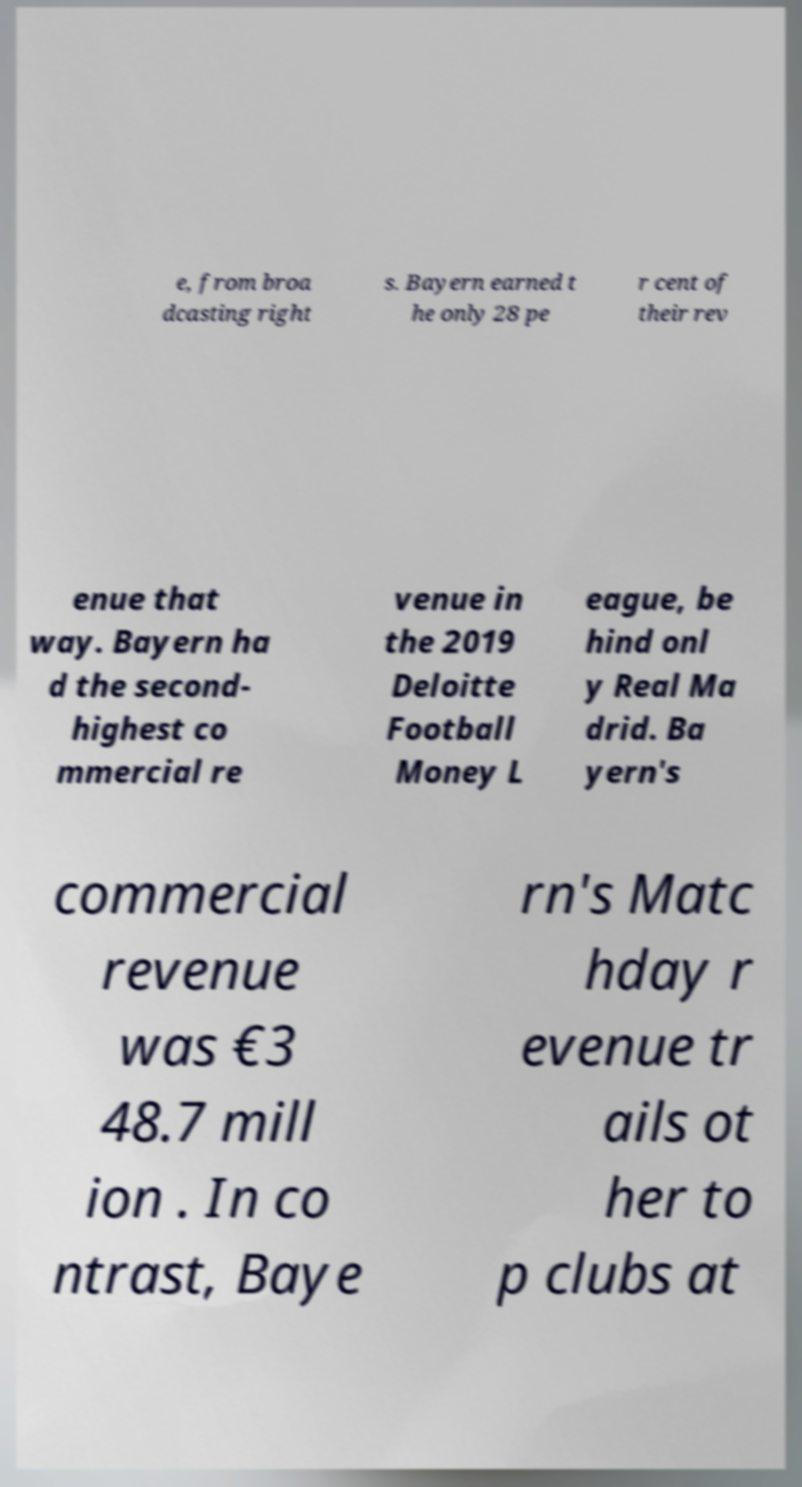Please identify and transcribe the text found in this image. e, from broa dcasting right s. Bayern earned t he only 28 pe r cent of their rev enue that way. Bayern ha d the second- highest co mmercial re venue in the 2019 Deloitte Football Money L eague, be hind onl y Real Ma drid. Ba yern's commercial revenue was €3 48.7 mill ion . In co ntrast, Baye rn's Matc hday r evenue tr ails ot her to p clubs at 